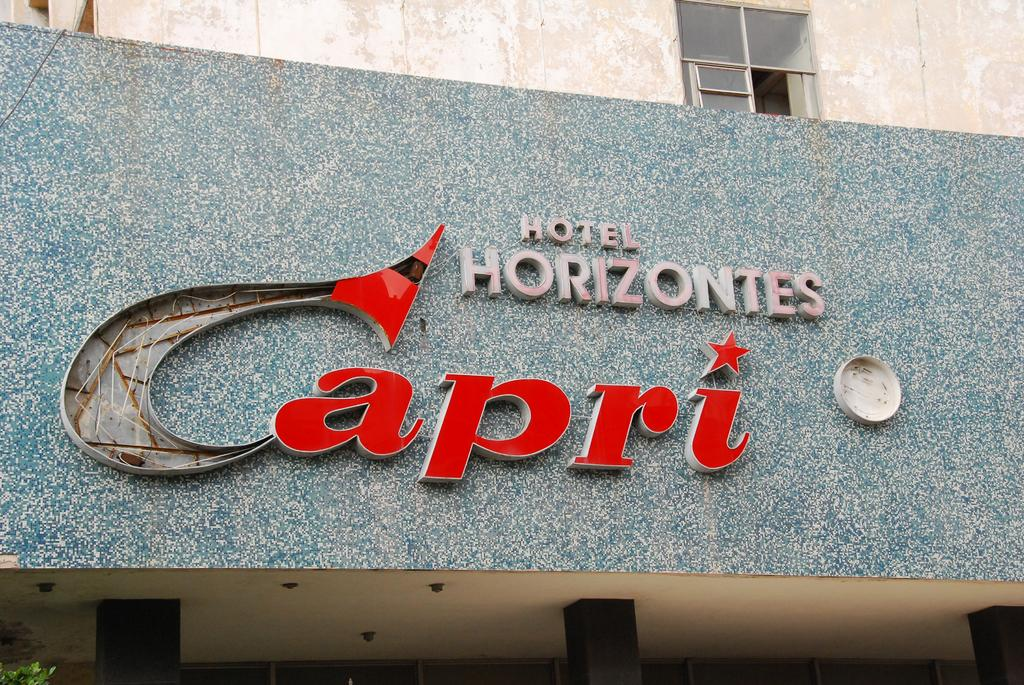Provide a one-sentence caption for the provided image. Big sign that says Hotel Horizontes Capri on a building. 